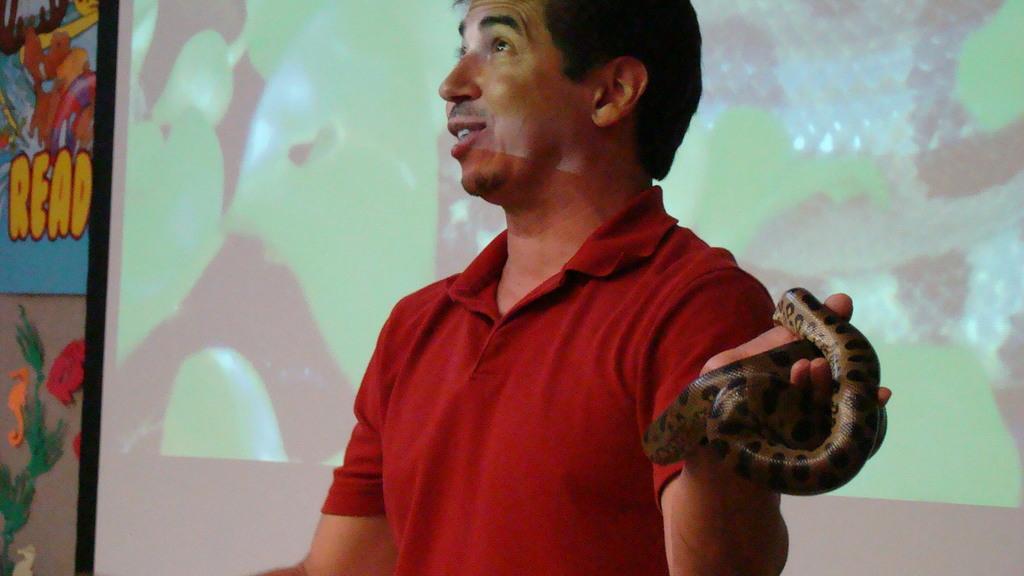How would you summarize this image in a sentence or two? In this image i can see a person wearing a red color t-shirt his mouth is open and i can see a colorful wall on the background and a person holding a snake on his hand. 